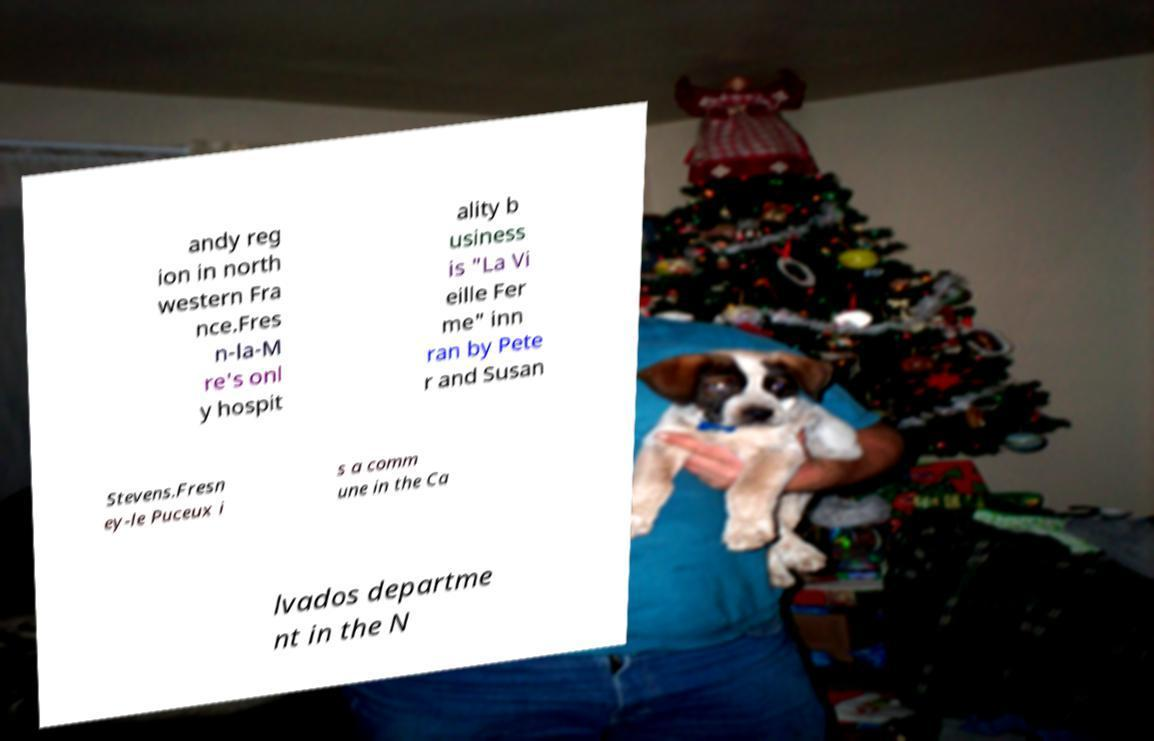What messages or text are displayed in this image? I need them in a readable, typed format. andy reg ion in north western Fra nce.Fres n-la-M re's onl y hospit ality b usiness is "La Vi eille Fer me" inn ran by Pete r and Susan Stevens.Fresn ey-le Puceux i s a comm une in the Ca lvados departme nt in the N 